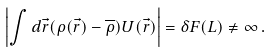<formula> <loc_0><loc_0><loc_500><loc_500>\left | \int d \vec { r } ( \rho ( \vec { r } ) - \overline { \rho } ) U ( \vec { r } ) \right | = \delta F ( L ) \ne \infty \, .</formula> 